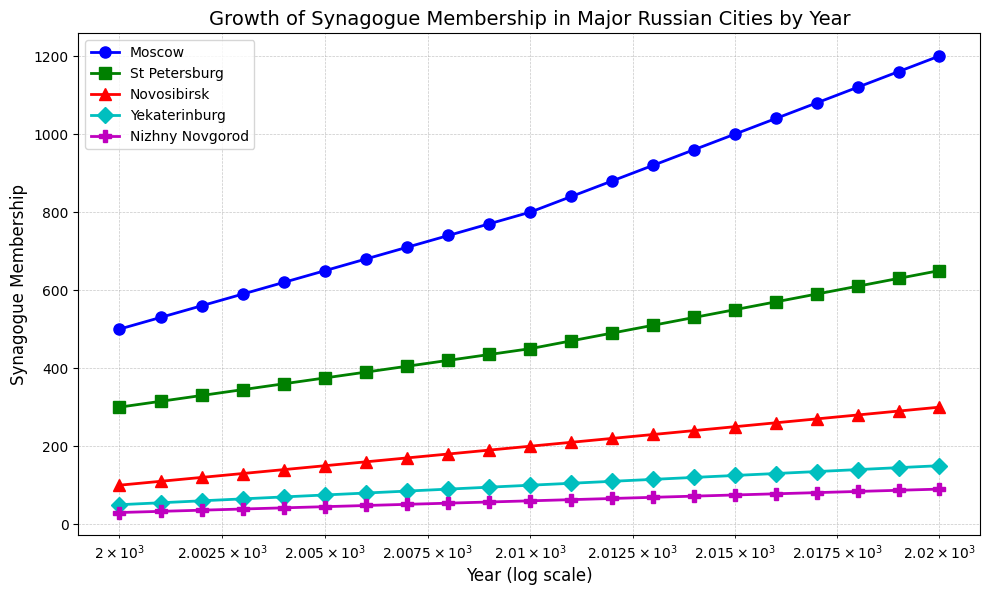Which city had the highest synagogue membership in 2020? By looking at the endpoint of each line in the figure, the endpoint with the highest value in 2020 belongs to Moscow.
Answer: Moscow Compare the growth of synagogue membership between Moscow and St. Petersburg. Which city had faster growth and by how much? Observing the slopes of the lines for Moscow and St. Petersburg, Moscow has a steeper slope. The membership in Moscow grew from 500 to 1200, an increase of 700, whereas St. Petersburg grew from 300 to 650, an increase of 350.
Answer: Moscow by 350 What is the approximate membership difference between Yekaterinburg and Novosibirsk in 2010? In 2010, estimating the respective y-values of Yekaterinburg and Novosibirsk from the chart gives us approximately 100 for Yekaterinburg and 200 for Novosibirsk. The difference is 200 - 100.
Answer: 100 Identify the city with the lowest synagogue membership in 2005 and 2020. The shortest line segment in 2005 corresponds to Nizhny Novgorod with about 45 members. Similarly, in 2020, Nizhny Novgorod still has the lowest membership, with approximately 90 members.
Answer: 2005: Nizhny Novgorod, 2020: Nizhny Novgorod Calculate the average increase in synagogue membership per year in Novosibirsk from 2000 to 2020. Novosibirsk's membership increased from 100 in 2000 to 300 in 2020. The total increase is 300 - 100 = 200 members over 20 years, thus the average increase per year is 200 / 20.
Answer: 10 members/year What year did St. Petersburg's synagogue membership reach 500? Identify the point on St. Petersburg's line that crosses the 500 members mark. This occurs in 2013.
Answer: 2013 Compare the trends of synagogue membership in Yekaterinburg and Nizhny Novgorod over the years. How do their growth patterns differ? Yekaterinburg's membership increased steadily from 50 to 150, whereas Nizhny Novgorod's membership rose more gradually from 30 to 90. This indicates that Yekaterinburg experienced a more pronounced growth trend than Nizhny Novgorod.
Answer: Yekaterinburg has a more pronounced growth trend than Nizhny Novgorod Which city showed the greatest membership increase from 2015 to 2020? Calculate the difference between membership numbers in 2015 and 2020 for each city. The largest increase occurred in Moscow, growing from 1000 to 1200. The increase is 1200 - 1000.
Answer: Moscow, 200 members What is the median synagogue membership for the cities in 2010? The membership numbers for 2010 are: Moscow (800), St. Petersburg (450), Novosibirsk (200), Yekaterinburg (100), Nizhny Novgorod (60). Arranging them in order: 60, 100, 200, 450, 800. The median is the middle value.
Answer: 200 members 